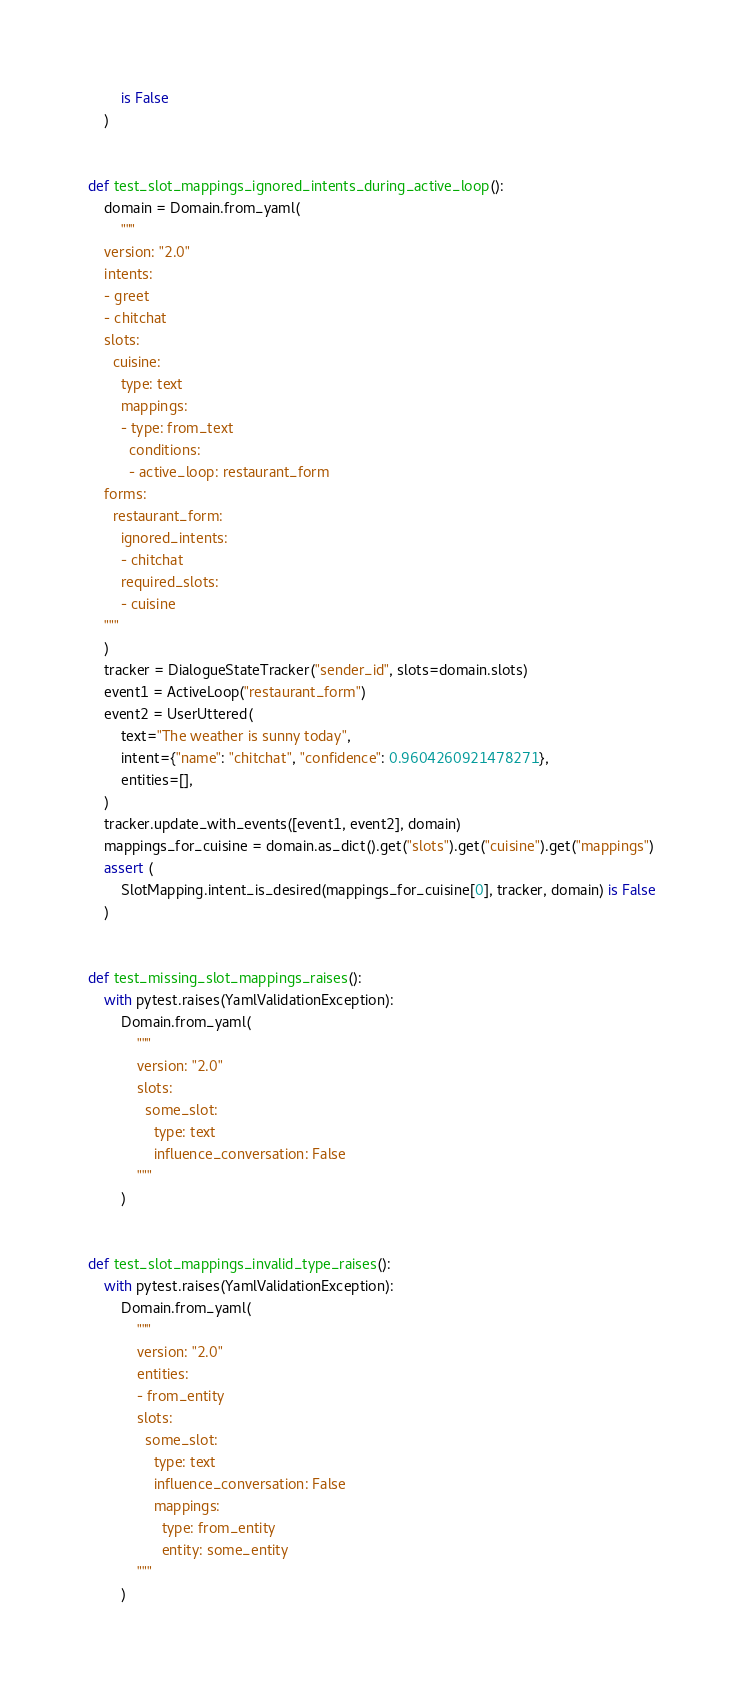Convert code to text. <code><loc_0><loc_0><loc_500><loc_500><_Python_>        is False
    )


def test_slot_mappings_ignored_intents_during_active_loop():
    domain = Domain.from_yaml(
        """
    version: "2.0"
    intents:
    - greet
    - chitchat
    slots:
      cuisine:
        type: text
        mappings:
        - type: from_text
          conditions:
          - active_loop: restaurant_form
    forms:
      restaurant_form:
        ignored_intents:
        - chitchat
        required_slots:
        - cuisine
    """
    )
    tracker = DialogueStateTracker("sender_id", slots=domain.slots)
    event1 = ActiveLoop("restaurant_form")
    event2 = UserUttered(
        text="The weather is sunny today",
        intent={"name": "chitchat", "confidence": 0.9604260921478271},
        entities=[],
    )
    tracker.update_with_events([event1, event2], domain)
    mappings_for_cuisine = domain.as_dict().get("slots").get("cuisine").get("mappings")
    assert (
        SlotMapping.intent_is_desired(mappings_for_cuisine[0], tracker, domain) is False
    )


def test_missing_slot_mappings_raises():
    with pytest.raises(YamlValidationException):
        Domain.from_yaml(
            """
            version: "2.0"
            slots:
              some_slot:
                type: text
                influence_conversation: False
            """
        )


def test_slot_mappings_invalid_type_raises():
    with pytest.raises(YamlValidationException):
        Domain.from_yaml(
            """
            version: "2.0"
            entities:
            - from_entity
            slots:
              some_slot:
                type: text
                influence_conversation: False
                mappings:
                  type: from_entity
                  entity: some_entity
            """
        )
</code> 